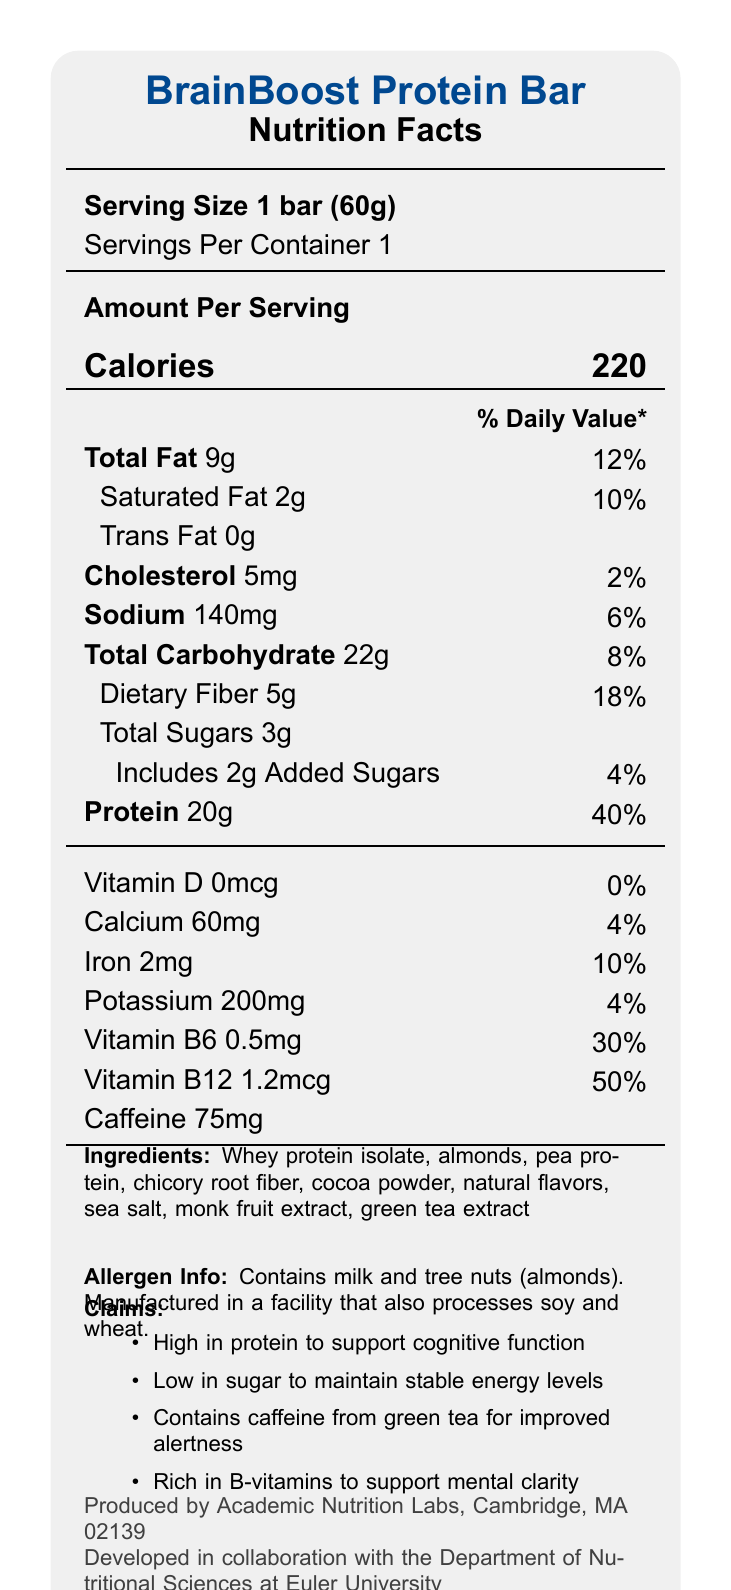what is the serving size for the BrainBoost Protein Bar? The serving size information is directly provided in the document under "Serving Size".
Answer: 1 bar (60g) how many calories are in one serving of the BrainBoost Protein Bar? The number of calories per serving is listed prominently in the nutrition facts label.
Answer: 220 how much protein does one bar contain? The protein content is listed under the nutrition facts with the amount per serving.
Answer: 20g what percentage of the daily value for vitamin B12 does the BrainBoost Protein Bar provide? This detail is found under the vitamin & nutrients section of the nutrition label.
Answer: 50% how much sodium is in one serving and what is its percentage of the daily value? Both the amount of sodium and the percentage of the daily value are clearly stated on the label.
Answer: 140mg, 6% which ingredient is used as a sweetener in this bar? The ingredients list includes monk fruit extract, commonly used as a natural sweetener.
Answer: Monk fruit extract what are the allergen warnings for this product? This information is located under the allergen info section of the nutrition label.
Answer: Contains milk and tree nuts (almonds). Manufactured in a facility that also processes soy and wheat. which vitamin is not present in the BrainBoost Protein Bar? A. Vitamin A B. Vitamin C C. Vitamin D D. Vitamin E The document specifies that Vitamin D is present in 0mcg (0% DV), whereas the other options are not mentioned.
Answer: C. Vitamin D what is the main source of caffeine in the BrainBoost Protein Bar? A. Coffee extract B. Green tea extract C. Cocoa powder D. Guarana Caffeine is listed in the document as coming from green tea extract.
Answer: B. Green tea extract is the BrainBoost Protein Bar low in sugar? The document states that the bar is low in sugar, containing only 3g of total sugars.
Answer: Yes summarize the main points of the BrainBoost Protein Bar's nutrition facts. This summary captures the key nutritional aspects, ingredient list, and endorsements related to the BrainBoost Protein Bar as presented in the document.
Answer: The BrainBoost Protein Bar is a low-sugar, high-protein snack designed to promote alertness and concentration. Each 60g bar contains 220 calories, 20g of protein, and 3g of total sugars. It includes notable amounts of B-vitamins and caffeine from green tea extract. The bar also provides a moderate amount of dietary fiber (5g) and is low in sodium (140mg). Ingredients include whey protein isolate, almonds, pea protein, and chicory root fiber. It contains allergens such as milk and tree nuts and is manufactured in a facility that processes soy and wheat. The snack is endorsed by the Department of Nutritional Sciences at Euler University. what is the exact amount of caffeine in the BrainBoost Protein Bar? The caffeine amount is explicitly listed at the bottom of the nutrition facts section.
Answer: 75mg how many grams of dietary fiber are present in one serving? The amount of dietary fiber appears in the nutrition information, with a percentage daily value noted as 18%.
Answer: 5g does the BrainBoost Protein Bar contain any trans fat? Trans fat is listed as 0g in the nutrition facts, indicating there is none in the product.
Answer: No is vitamin C included in the nutrition facts of the BrainBoost Protein Bar? Vitamin C is not listed in the provided nutrition facts, so its presence or absence cannot be determined from the document.
Answer: Not mentioned where is the BrainBoost Protein Bar manufactured? The manufacturing location is at the end of the document, listed as produced by Academic Nutrition Labs in Cambridge, MA.
Answer: Cambridge, MA what collaboration is mentioned in the production of this bar? This collaboration detail is included in the claim statements at the bottom of the document.
Answer: Collaboration with the Department of Nutritional Sciences at Euler University 